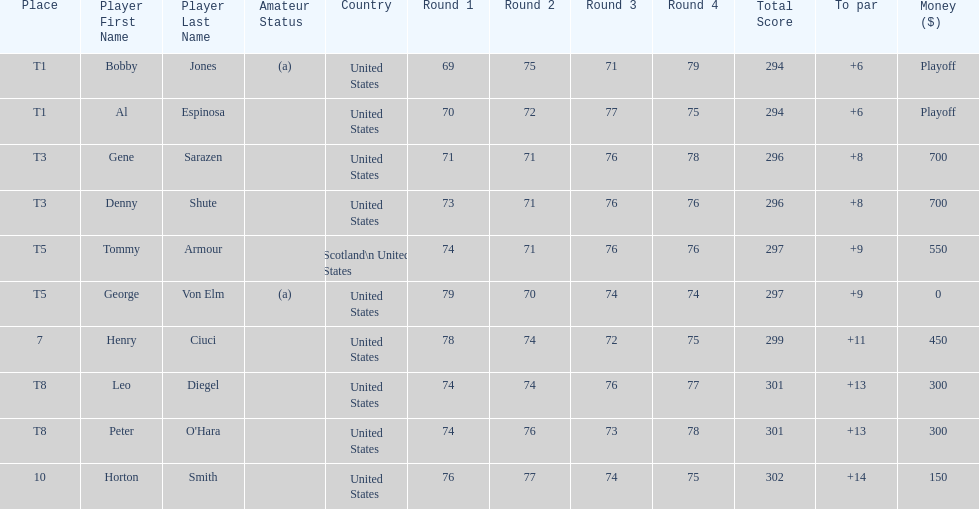How many players represented scotland? 1. 